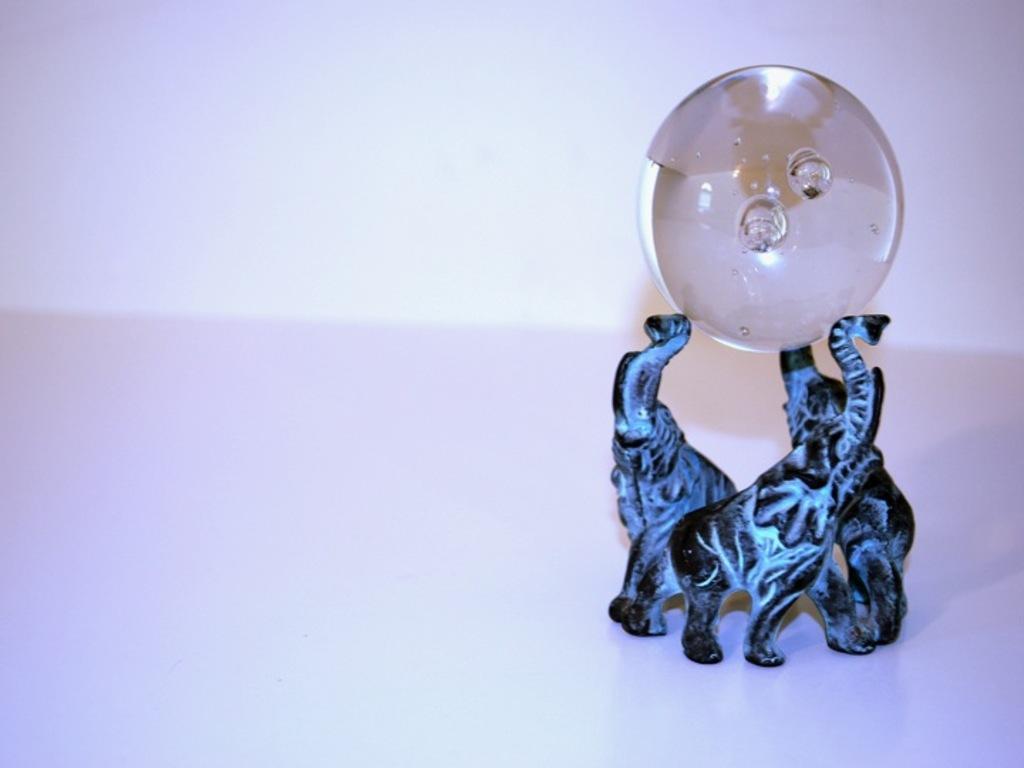Please provide a concise description of this image. There is sculpture at the right holding a circular object. The background is white. 